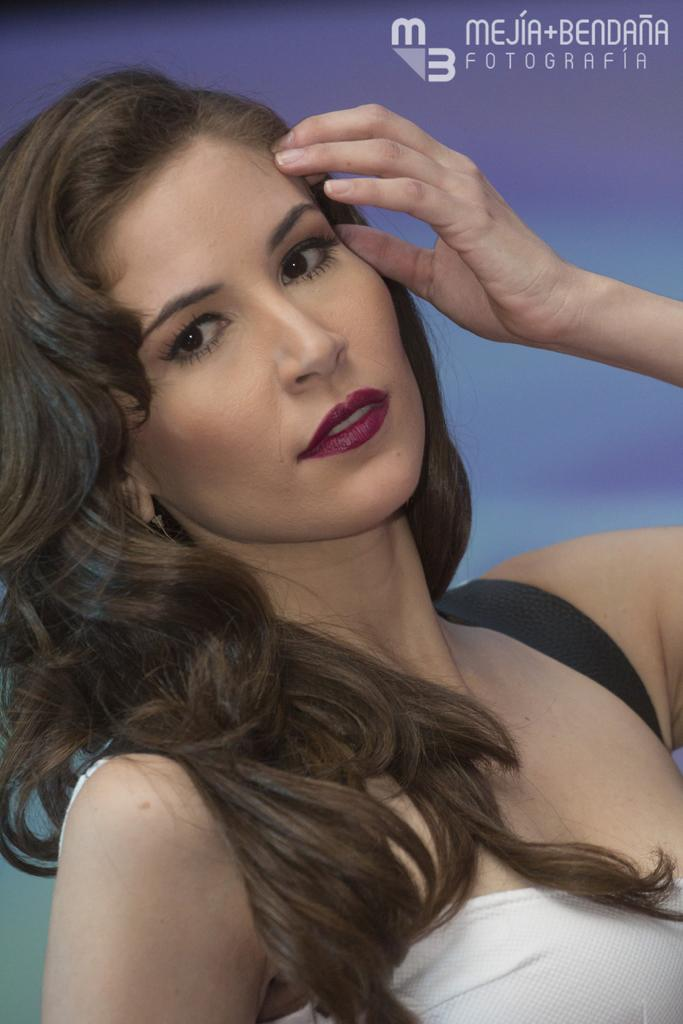What is the main subject of the image? There is a woman standing in the image. Can you describe the background of the image? The background of the image is colorful. Is there any text present in the image? Yes, there is some text present in the image. How many toes can be seen on the woman's feet in the image? The image does not show the woman's feet, so it is not possible to determine the number of toes. 